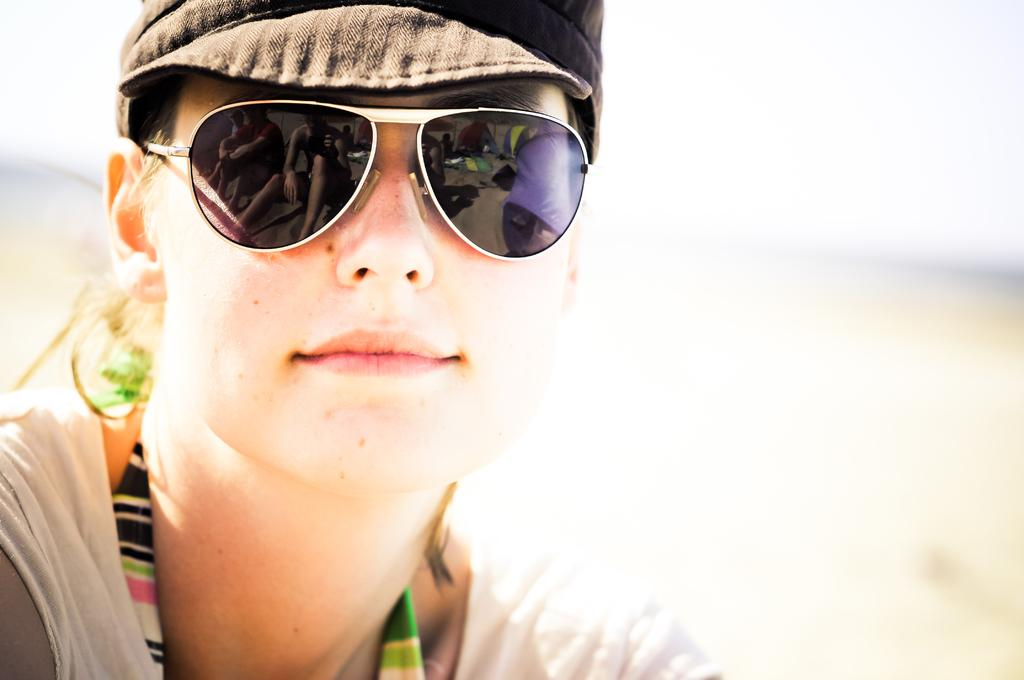Who is present in the image? There is a woman in the image. What protective gear is the woman wearing? The woman is wearing goggles. What type of headwear is the woman wearing? The woman is wearing a cap. What color is the woman's t-shirt? The woman is wearing a white color t-shirt. What type of wood is the pan made of in the image? There is no pan present in the image, so it is not possible to determine what type of wood it might be made of. 